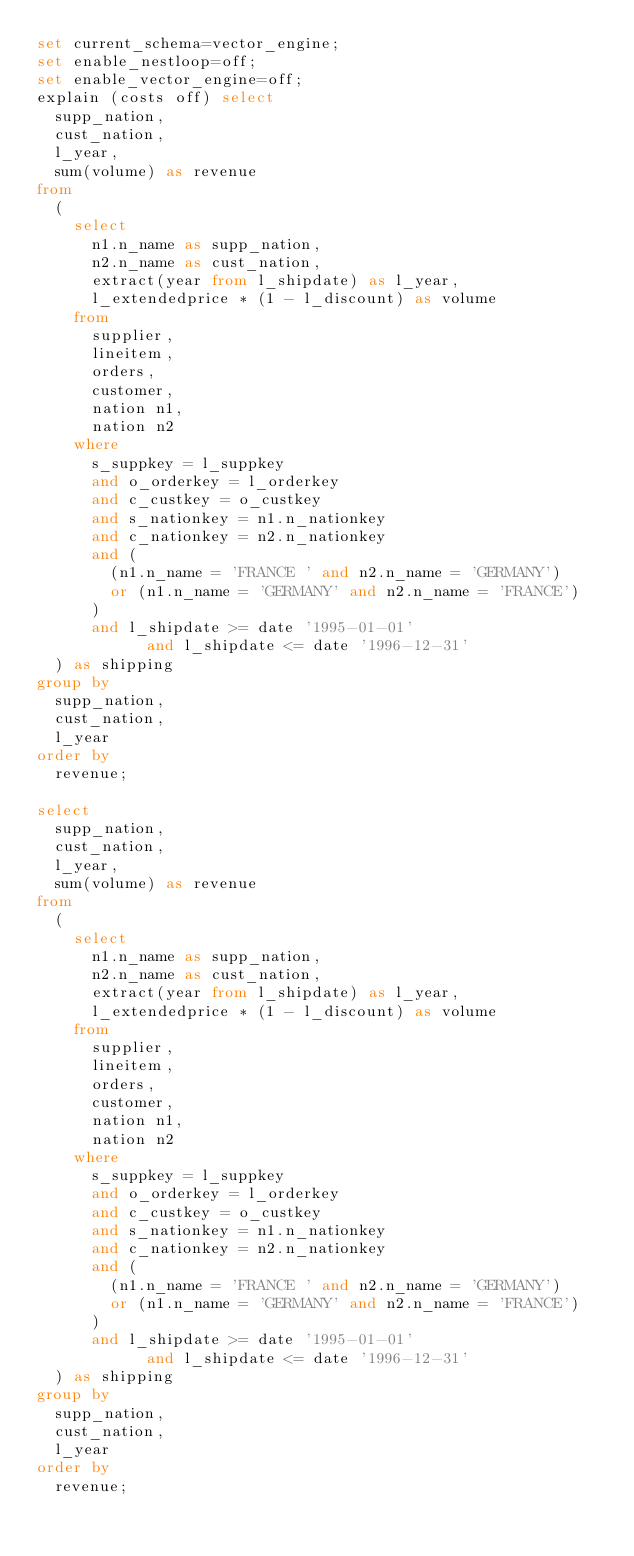<code> <loc_0><loc_0><loc_500><loc_500><_SQL_>set current_schema=vector_engine;
set enable_nestloop=off;
set enable_vector_engine=off;
explain (costs off) select
	supp_nation,
	cust_nation,
	l_year,
	sum(volume) as revenue
from
	(
		select
			n1.n_name as supp_nation,
			n2.n_name as cust_nation,
			extract(year from l_shipdate) as l_year,
			l_extendedprice * (1 - l_discount) as volume
		from
			supplier,
			lineitem,
			orders,
			customer,
			nation n1,
			nation n2
		where
			s_suppkey = l_suppkey
			and o_orderkey = l_orderkey
			and c_custkey = o_custkey
			and s_nationkey = n1.n_nationkey
			and c_nationkey = n2.n_nationkey
			and (
				(n1.n_name = 'FRANCE ' and n2.n_name = 'GERMANY')
				or (n1.n_name = 'GERMANY' and n2.n_name = 'FRANCE')
			)
			and l_shipdate >= date '1995-01-01'
            and l_shipdate <= date '1996-12-31'
	) as shipping
group by
	supp_nation,
	cust_nation,
	l_year
order by 
	revenue;

select
	supp_nation,
	cust_nation,
	l_year,
	sum(volume) as revenue
from
	(
		select
			n1.n_name as supp_nation,
			n2.n_name as cust_nation,
			extract(year from l_shipdate) as l_year,
			l_extendedprice * (1 - l_discount) as volume
		from
			supplier,
			lineitem,
			orders,
			customer,
			nation n1,
			nation n2
		where
			s_suppkey = l_suppkey
			and o_orderkey = l_orderkey
			and c_custkey = o_custkey
			and s_nationkey = n1.n_nationkey
			and c_nationkey = n2.n_nationkey
			and (
				(n1.n_name = 'FRANCE ' and n2.n_name = 'GERMANY')
				or (n1.n_name = 'GERMANY' and n2.n_name = 'FRANCE')
			)
			and l_shipdate >= date '1995-01-01'
            and l_shipdate <= date '1996-12-31'
	) as shipping
group by
	supp_nation,
	cust_nation,
	l_year
order by 
	revenue;
</code> 